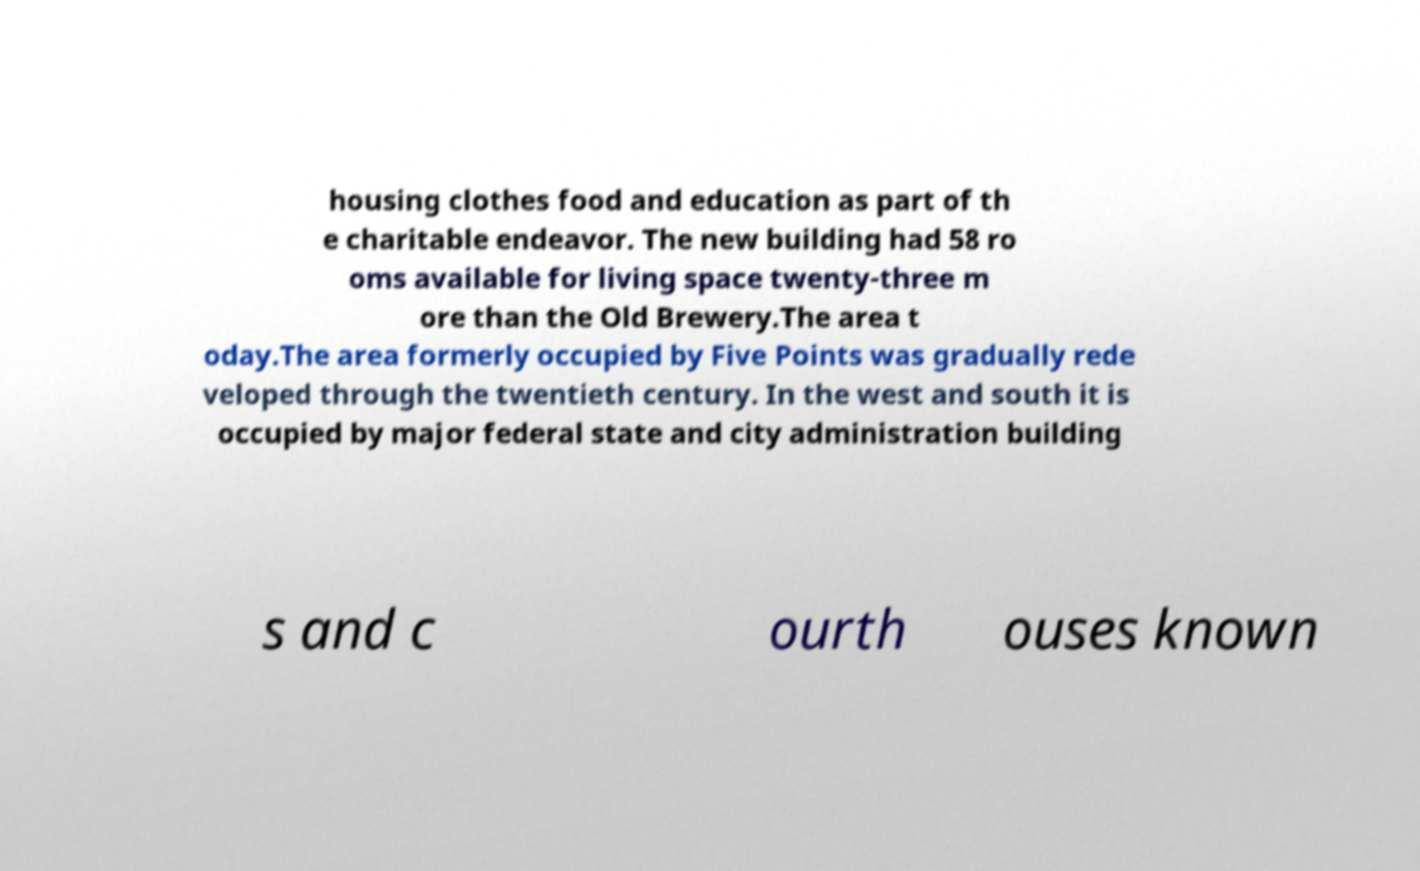Could you extract and type out the text from this image? housing clothes food and education as part of th e charitable endeavor. The new building had 58 ro oms available for living space twenty-three m ore than the Old Brewery.The area t oday.The area formerly occupied by Five Points was gradually rede veloped through the twentieth century. In the west and south it is occupied by major federal state and city administration building s and c ourth ouses known 